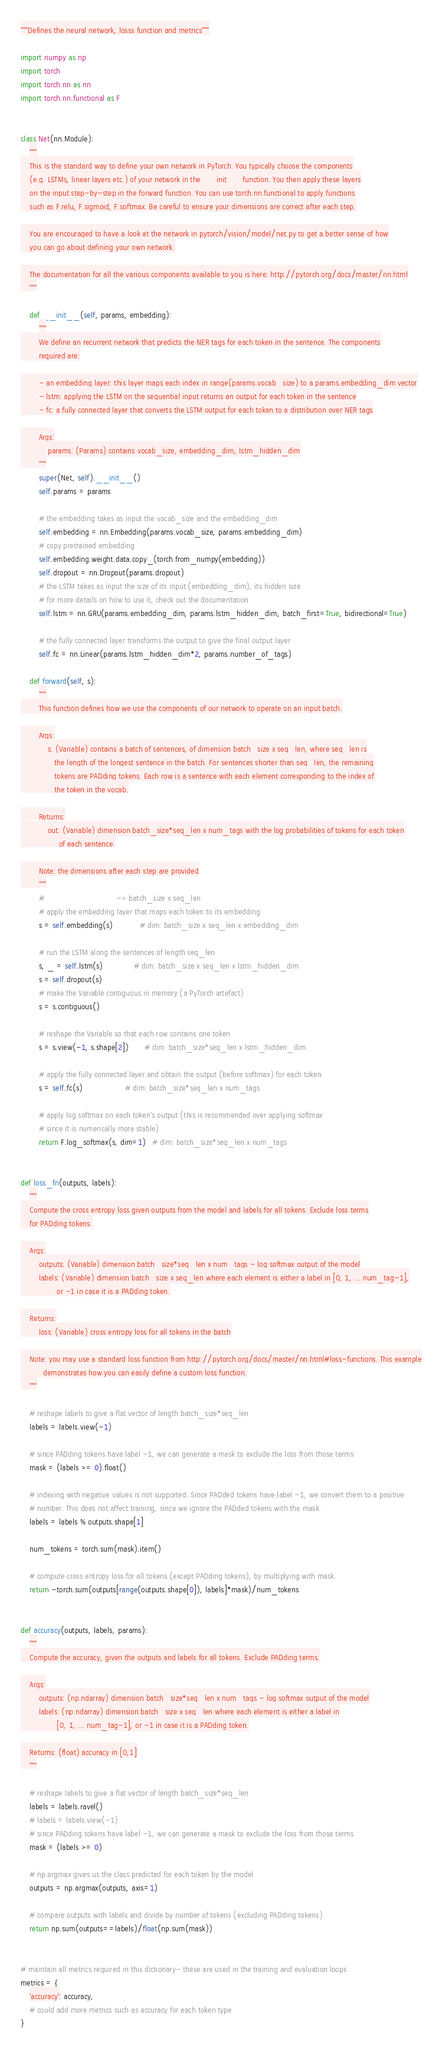<code> <loc_0><loc_0><loc_500><loc_500><_Python_>"""Defines the neural network, losss function and metrics"""

import numpy as np
import torch
import torch.nn as nn
import torch.nn.functional as F


class Net(nn.Module):
    """
    This is the standard way to define your own network in PyTorch. You typically choose the components
    (e.g. LSTMs, linear layers etc.) of your network in the __init__ function. You then apply these layers
    on the input step-by-step in the forward function. You can use torch.nn.functional to apply functions
    such as F.relu, F.sigmoid, F.softmax. Be careful to ensure your dimensions are correct after each step.

    You are encouraged to have a look at the network in pytorch/vision/model/net.py to get a better sense of how
    you can go about defining your own network.

    The documentation for all the various components available to you is here: http://pytorch.org/docs/master/nn.html
    """

    def __init__(self, params, embedding):
        """
        We define an recurrent network that predicts the NER tags for each token in the sentence. The components
        required are:

        - an embedding layer: this layer maps each index in range(params.vocab_size) to a params.embedding_dim vector
        - lstm: applying the LSTM on the sequential input returns an output for each token in the sentence
        - fc: a fully connected layer that converts the LSTM output for each token to a distribution over NER tags

        Args:
            params: (Params) contains vocab_size, embedding_dim, lstm_hidden_dim
        """
        super(Net, self).__init__()
        self.params = params

        # the embedding takes as input the vocab_size and the embedding_dim
        self.embedding = nn.Embedding(params.vocab_size, params.embedding_dim)
        # copy pretrained embedding
        self.embedding.weight.data.copy_(torch.from_numpy(embedding))
        self.dropout = nn.Dropout(params.dropout)
        # the LSTM takes as input the size of its input (embedding_dim), its hidden size
        # for more details on how to use it, check out the documentation
        self.lstm = nn.GRU(params.embedding_dim, params.lstm_hidden_dim, batch_first=True, bidirectional=True)

        # the fully connected layer transforms the output to give the final output layer
        self.fc = nn.Linear(params.lstm_hidden_dim*2, params.number_of_tags)
        
    def forward(self, s):
        """
        This function defines how we use the components of our network to operate on an input batch.

        Args:
            s: (Variable) contains a batch of sentences, of dimension batch_size x seq_len, where seq_len is
               the length of the longest sentence in the batch. For sentences shorter than seq_len, the remaining
               tokens are PADding tokens. Each row is a sentence with each element corresponding to the index of
               the token in the vocab.

        Returns:
            out: (Variable) dimension batch_size*seq_len x num_tags with the log probabilities of tokens for each token
                 of each sentence.

        Note: the dimensions after each step are provided
        """
        #                                -> batch_size x seq_len
        # apply the embedding layer that maps each token to its embedding
        s = self.embedding(s)            # dim: batch_size x seq_len x embedding_dim

        # run the LSTM along the sentences of length seq_len
        s, _ = self.lstm(s)              # dim: batch_size x seq_len x lstm_hidden_dim
        s = self.dropout(s)
        # make the Variable contiguous in memory (a PyTorch artefact)
        s = s.contiguous()

        # reshape the Variable so that each row contains one token
        s = s.view(-1, s.shape[2])       # dim: batch_size*seq_len x lstm_hidden_dim

        # apply the fully connected layer and obtain the output (before softmax) for each token
        s = self.fc(s)                   # dim: batch_size*seq_len x num_tags

        # apply log softmax on each token's output (this is recommended over applying softmax
        # since it is numerically more stable)
        return F.log_softmax(s, dim=1)   # dim: batch_size*seq_len x num_tags


def loss_fn(outputs, labels):
    """
    Compute the cross entropy loss given outputs from the model and labels for all tokens. Exclude loss terms
    for PADding tokens.

    Args:
        outputs: (Variable) dimension batch_size*seq_len x num_tags - log softmax output of the model
        labels: (Variable) dimension batch_size x seq_len where each element is either a label in [0, 1, ... num_tag-1],
                or -1 in case it is a PADding token.

    Returns:
        loss: (Variable) cross entropy loss for all tokens in the batch

    Note: you may use a standard loss function from http://pytorch.org/docs/master/nn.html#loss-functions. This example
          demonstrates how you can easily define a custom loss function.
    """

    # reshape labels to give a flat vector of length batch_size*seq_len
    labels = labels.view(-1)

    # since PADding tokens have label -1, we can generate a mask to exclude the loss from those terms
    mask = (labels >= 0).float()

    # indexing with negative values is not supported. Since PADded tokens have label -1, we convert them to a positive
    # number. This does not affect training, since we ignore the PADded tokens with the mask.
    labels = labels % outputs.shape[1]

    num_tokens = torch.sum(mask).item()

    # compute cross entropy loss for all tokens (except PADding tokens), by multiplying with mask.
    return -torch.sum(outputs[range(outputs.shape[0]), labels]*mask)/num_tokens
    
    
def accuracy(outputs, labels, params):
    """
    Compute the accuracy, given the outputs and labels for all tokens. Exclude PADding terms.

    Args:
        outputs: (np.ndarray) dimension batch_size*seq_len x num_tags - log softmax output of the model
        labels: (np.ndarray) dimension batch_size x seq_len where each element is either a label in
                [0, 1, ... num_tag-1], or -1 in case it is a PADding token.

    Returns: (float) accuracy in [0,1]
    """

    # reshape labels to give a flat vector of length batch_size*seq_len
    labels = labels.ravel()
    # labels = labels.view(-1)
    # since PADding tokens have label -1, we can generate a mask to exclude the loss from those terms
    mask = (labels >= 0)

    # np.argmax gives us the class predicted for each token by the model
    outputs = np.argmax(outputs, axis=1)

    # compare outputs with labels and divide by number of tokens (excluding PADding tokens)
    return np.sum(outputs==labels)/float(np.sum(mask))


# maintain all metrics required in this dictionary- these are used in the training and evaluation loops
metrics = {
    'accuracy': accuracy,
    # could add more metrics such as accuracy for each token type
}
</code> 